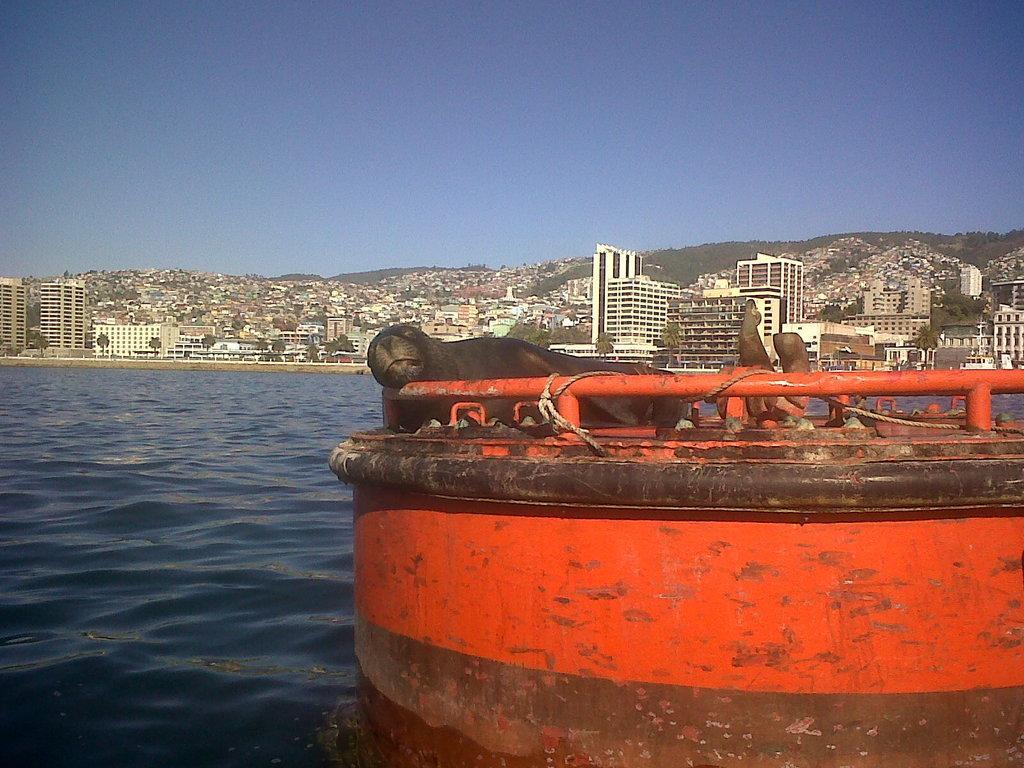Please provide a concise description of this image. In the picture we can see a red color part of a boat in the water on the boat we can see a sea lion and near it, we can see water and far away from it, we can see buildings, trees, tower buildings and a hill covered with houses and in the background we can see a sky. 